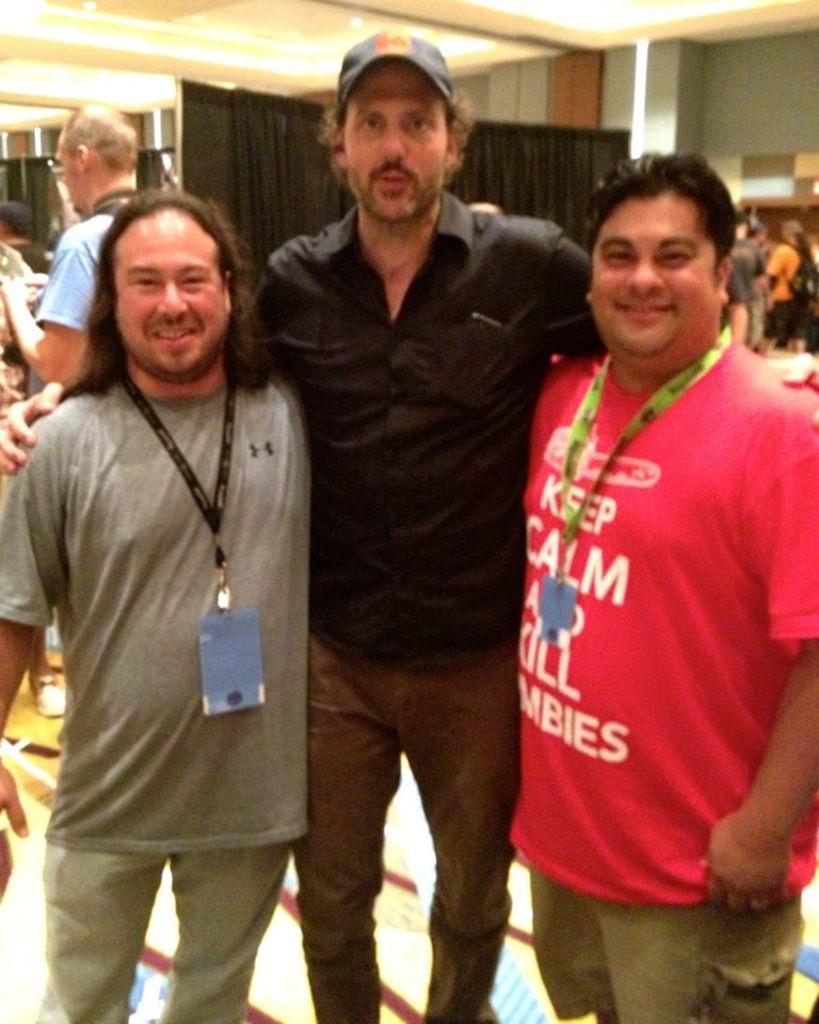Could you give a brief overview of what you see in this image? This picture is clicked inside. In the foreground we can see the three men standing on the ground. In the background we can see the wall, roof, ceiling lights, curtain, group of persons and some other objects. 